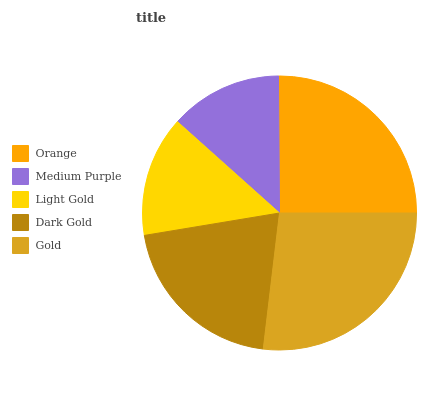Is Medium Purple the minimum?
Answer yes or no. Yes. Is Gold the maximum?
Answer yes or no. Yes. Is Light Gold the minimum?
Answer yes or no. No. Is Light Gold the maximum?
Answer yes or no. No. Is Light Gold greater than Medium Purple?
Answer yes or no. Yes. Is Medium Purple less than Light Gold?
Answer yes or no. Yes. Is Medium Purple greater than Light Gold?
Answer yes or no. No. Is Light Gold less than Medium Purple?
Answer yes or no. No. Is Dark Gold the high median?
Answer yes or no. Yes. Is Dark Gold the low median?
Answer yes or no. Yes. Is Light Gold the high median?
Answer yes or no. No. Is Medium Purple the low median?
Answer yes or no. No. 